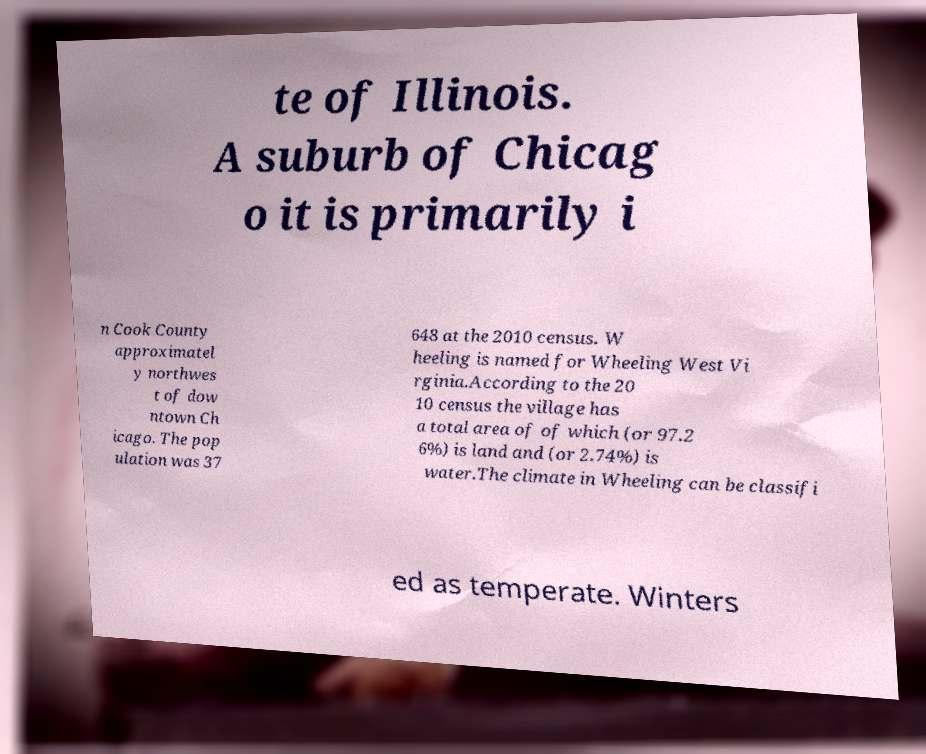Can you accurately transcribe the text from the provided image for me? te of Illinois. A suburb of Chicag o it is primarily i n Cook County approximatel y northwes t of dow ntown Ch icago. The pop ulation was 37 648 at the 2010 census. W heeling is named for Wheeling West Vi rginia.According to the 20 10 census the village has a total area of of which (or 97.2 6%) is land and (or 2.74%) is water.The climate in Wheeling can be classifi ed as temperate. Winters 